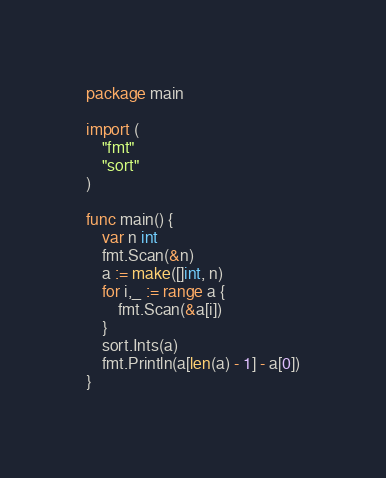Convert code to text. <code><loc_0><loc_0><loc_500><loc_500><_Go_>package main

import (
	"fmt"
	"sort"
)

func main() {
	var n int
	fmt.Scan(&n)
	a := make([]int, n)
	for i,_ := range a {
		fmt.Scan(&a[i])
	}
	sort.Ints(a)
	fmt.Println(a[len(a) - 1] - a[0])
}
</code> 